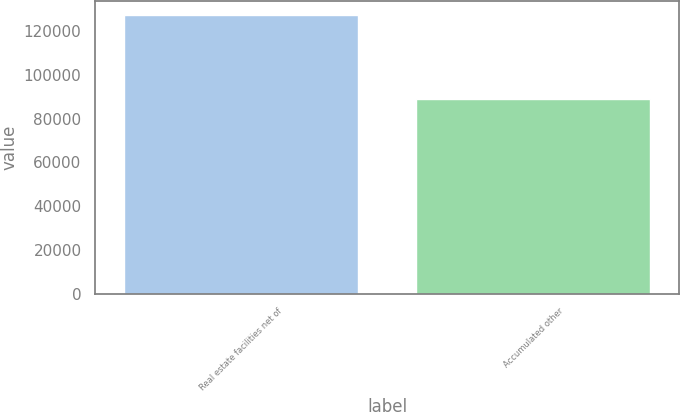Convert chart. <chart><loc_0><loc_0><loc_500><loc_500><bar_chart><fcel>Real estate facilities net of<fcel>Accumulated other<nl><fcel>127456<fcel>89180<nl></chart> 